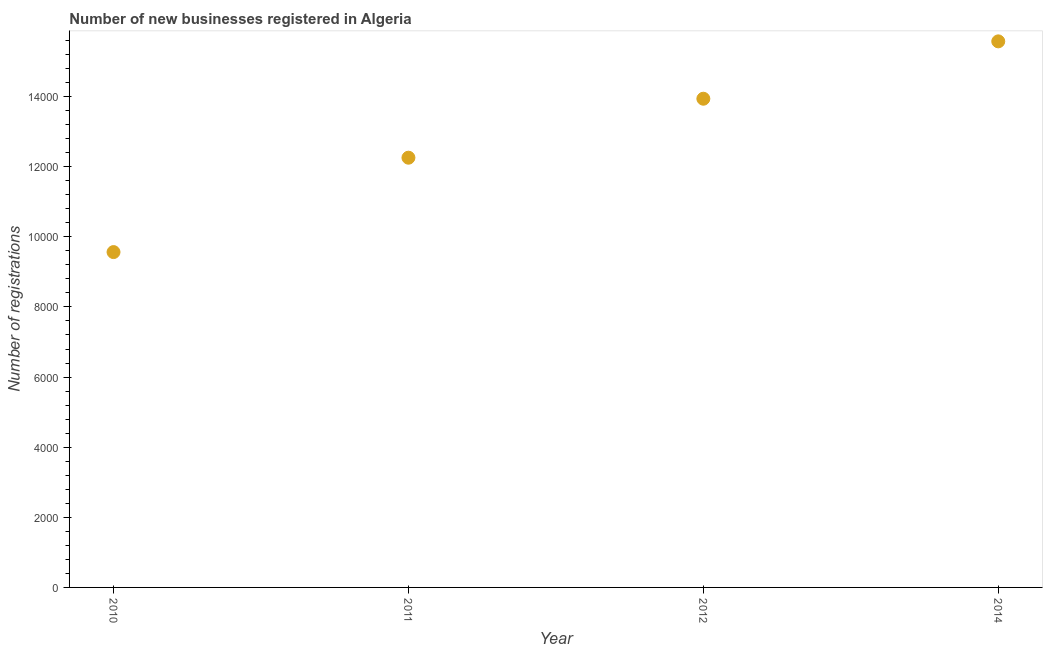What is the number of new business registrations in 2011?
Offer a very short reply. 1.23e+04. Across all years, what is the maximum number of new business registrations?
Offer a terse response. 1.56e+04. Across all years, what is the minimum number of new business registrations?
Provide a succinct answer. 9564. In which year was the number of new business registrations minimum?
Offer a terse response. 2010. What is the sum of the number of new business registrations?
Ensure brevity in your answer.  5.13e+04. What is the difference between the number of new business registrations in 2011 and 2012?
Make the answer very short. -1682. What is the average number of new business registrations per year?
Ensure brevity in your answer.  1.28e+04. What is the median number of new business registrations?
Keep it short and to the point. 1.31e+04. In how many years, is the number of new business registrations greater than 6400 ?
Offer a terse response. 4. What is the ratio of the number of new business registrations in 2010 to that in 2012?
Offer a very short reply. 0.69. Is the number of new business registrations in 2010 less than that in 2012?
Your response must be concise. Yes. What is the difference between the highest and the second highest number of new business registrations?
Give a very brief answer. 1636. What is the difference between the highest and the lowest number of new business registrations?
Give a very brief answer. 6010. In how many years, is the number of new business registrations greater than the average number of new business registrations taken over all years?
Offer a terse response. 2. How many dotlines are there?
Offer a very short reply. 1. Are the values on the major ticks of Y-axis written in scientific E-notation?
Ensure brevity in your answer.  No. Does the graph contain grids?
Provide a succinct answer. No. What is the title of the graph?
Offer a very short reply. Number of new businesses registered in Algeria. What is the label or title of the X-axis?
Your answer should be very brief. Year. What is the label or title of the Y-axis?
Offer a very short reply. Number of registrations. What is the Number of registrations in 2010?
Your answer should be very brief. 9564. What is the Number of registrations in 2011?
Make the answer very short. 1.23e+04. What is the Number of registrations in 2012?
Your answer should be compact. 1.39e+04. What is the Number of registrations in 2014?
Offer a very short reply. 1.56e+04. What is the difference between the Number of registrations in 2010 and 2011?
Ensure brevity in your answer.  -2692. What is the difference between the Number of registrations in 2010 and 2012?
Make the answer very short. -4374. What is the difference between the Number of registrations in 2010 and 2014?
Keep it short and to the point. -6010. What is the difference between the Number of registrations in 2011 and 2012?
Offer a very short reply. -1682. What is the difference between the Number of registrations in 2011 and 2014?
Give a very brief answer. -3318. What is the difference between the Number of registrations in 2012 and 2014?
Your answer should be very brief. -1636. What is the ratio of the Number of registrations in 2010 to that in 2011?
Provide a succinct answer. 0.78. What is the ratio of the Number of registrations in 2010 to that in 2012?
Keep it short and to the point. 0.69. What is the ratio of the Number of registrations in 2010 to that in 2014?
Give a very brief answer. 0.61. What is the ratio of the Number of registrations in 2011 to that in 2012?
Offer a very short reply. 0.88. What is the ratio of the Number of registrations in 2011 to that in 2014?
Offer a very short reply. 0.79. What is the ratio of the Number of registrations in 2012 to that in 2014?
Your response must be concise. 0.9. 